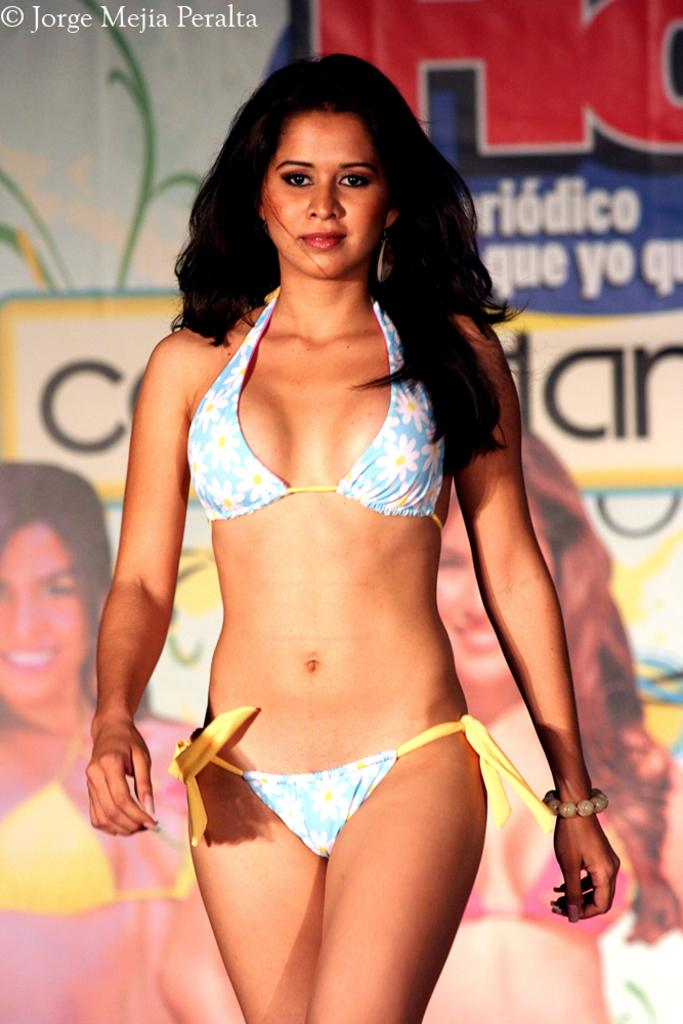Who is the main subject in the image? There is a woman in the image. What is the woman wearing? The woman is wearing a bikini. What is the woman doing in the image? The woman is walking. What else can be seen in the image? There is a banner in the image. What is the woman's income based on the image? There is no information about the woman's income in the image. Can you touch the banner in the image? The image is a visual representation, and you cannot physically touch or interact with it. 